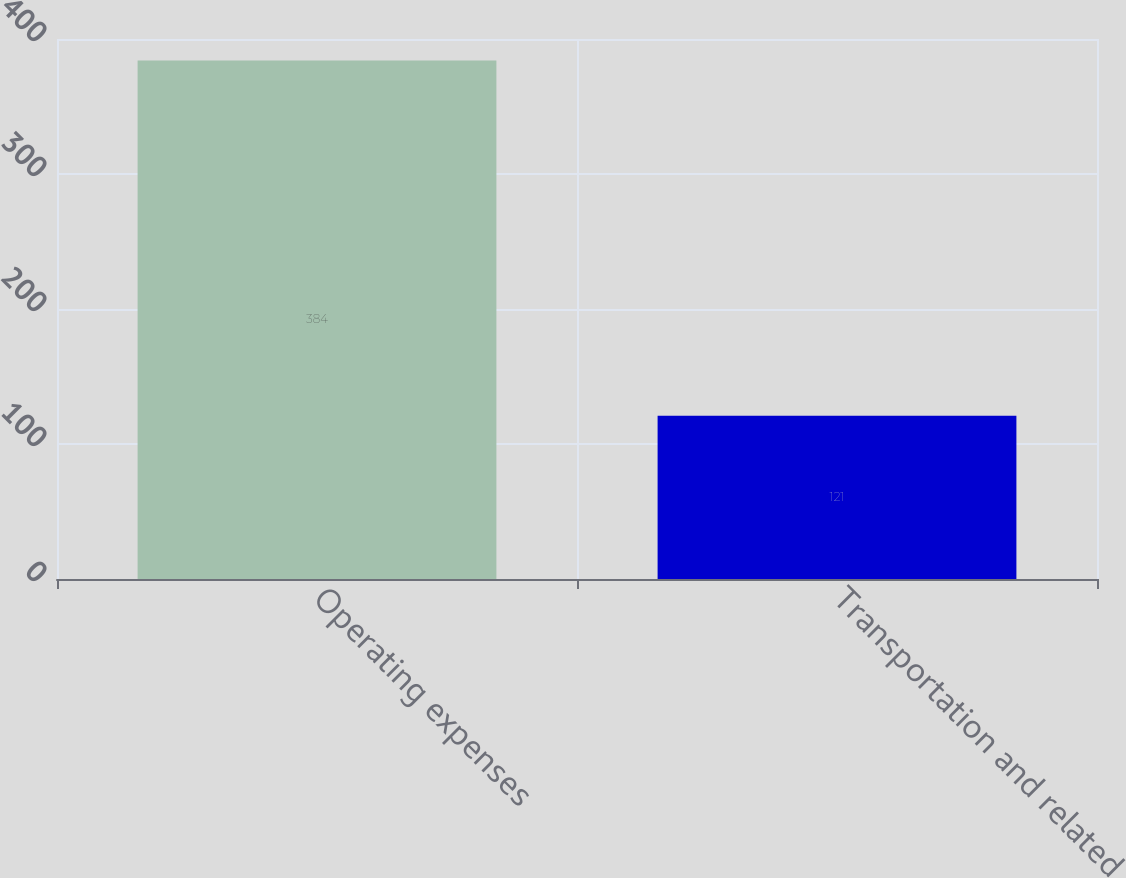<chart> <loc_0><loc_0><loc_500><loc_500><bar_chart><fcel>Operating expenses<fcel>Transportation and related<nl><fcel>384<fcel>121<nl></chart> 